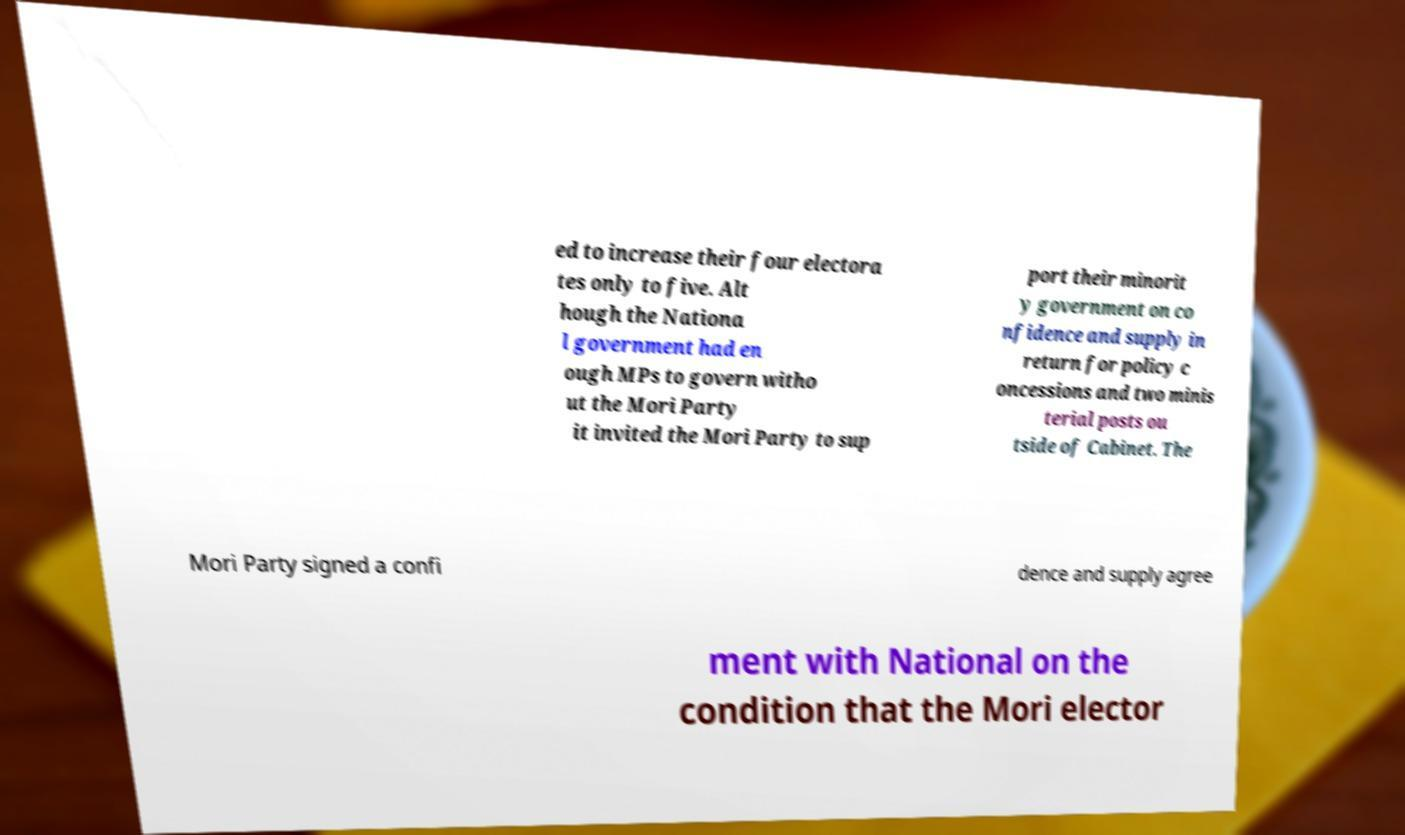I need the written content from this picture converted into text. Can you do that? ed to increase their four electora tes only to five. Alt hough the Nationa l government had en ough MPs to govern witho ut the Mori Party it invited the Mori Party to sup port their minorit y government on co nfidence and supply in return for policy c oncessions and two minis terial posts ou tside of Cabinet. The Mori Party signed a confi dence and supply agree ment with National on the condition that the Mori elector 